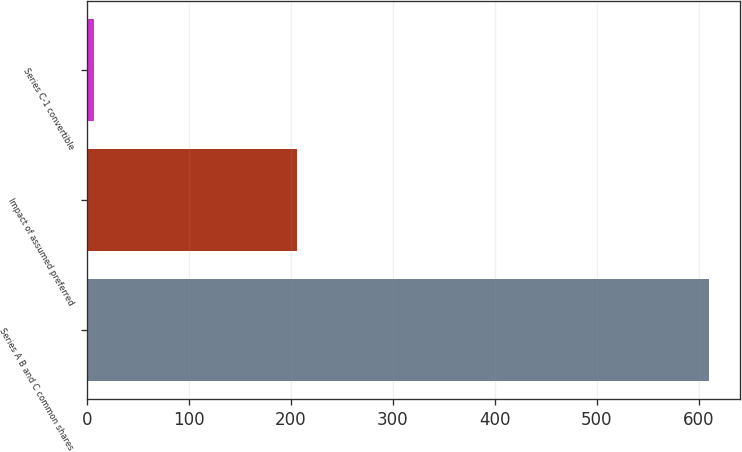Convert chart to OTSL. <chart><loc_0><loc_0><loc_500><loc_500><bar_chart><fcel>Series A B and C common shares<fcel>Impact of assumed preferred<fcel>Series C-1 convertible<nl><fcel>610<fcel>206<fcel>7<nl></chart> 